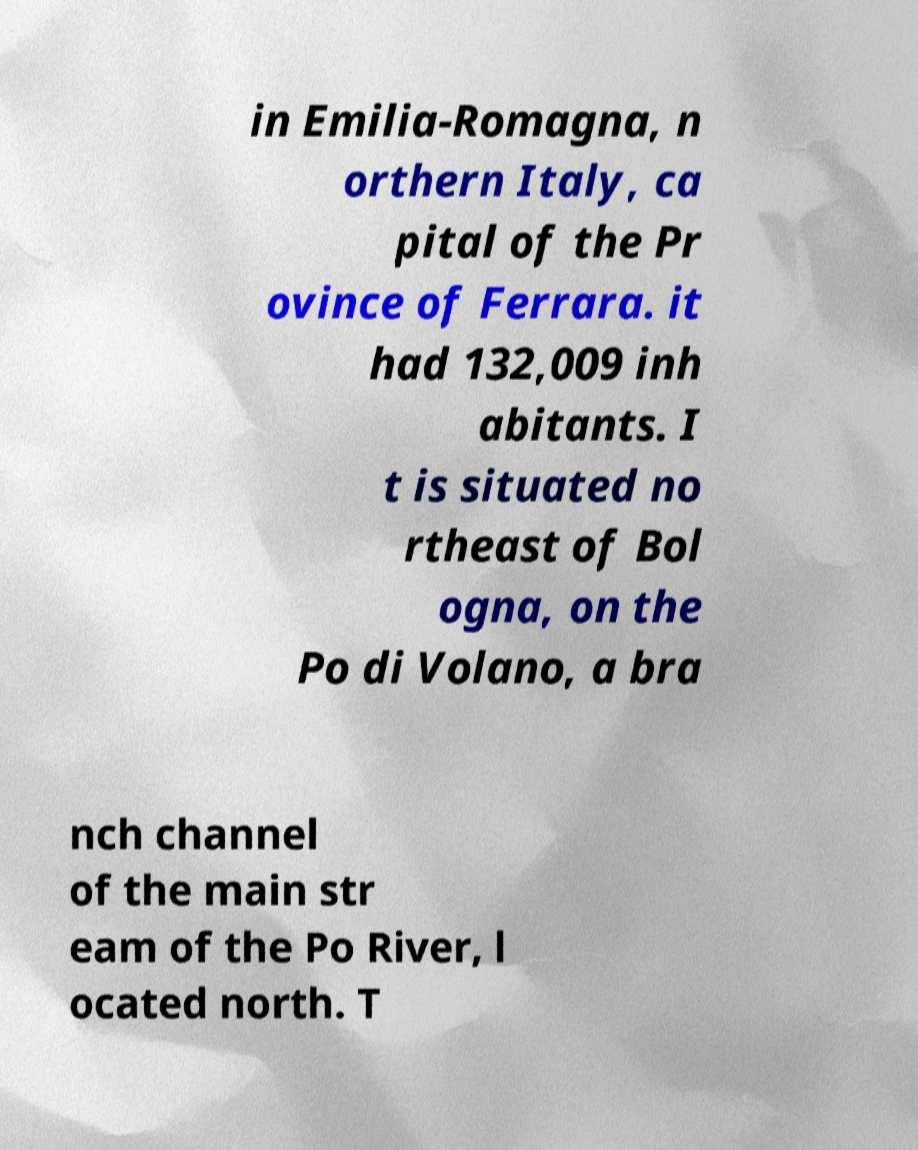What messages or text are displayed in this image? I need them in a readable, typed format. in Emilia-Romagna, n orthern Italy, ca pital of the Pr ovince of Ferrara. it had 132,009 inh abitants. I t is situated no rtheast of Bol ogna, on the Po di Volano, a bra nch channel of the main str eam of the Po River, l ocated north. T 